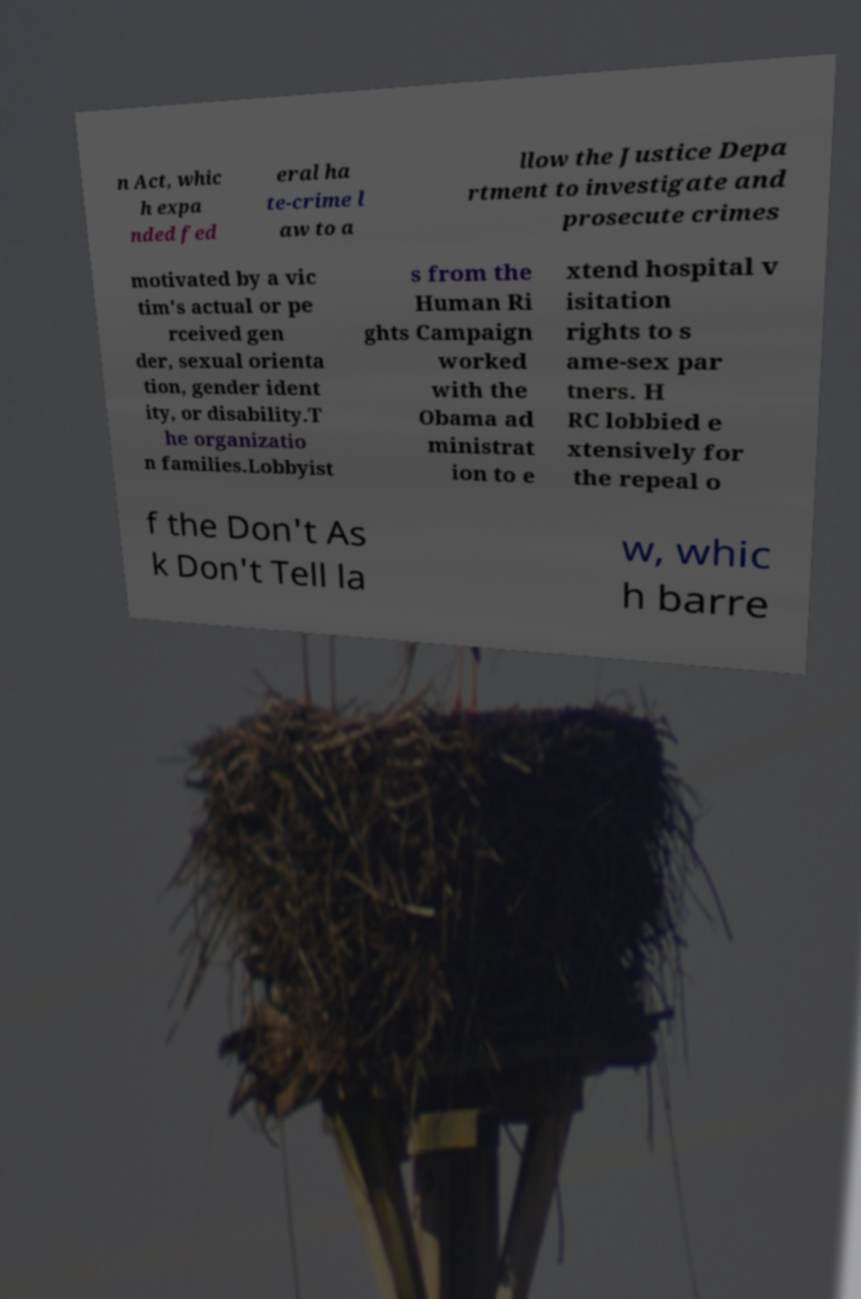Please read and relay the text visible in this image. What does it say? n Act, whic h expa nded fed eral ha te-crime l aw to a llow the Justice Depa rtment to investigate and prosecute crimes motivated by a vic tim's actual or pe rceived gen der, sexual orienta tion, gender ident ity, or disability.T he organizatio n families.Lobbyist s from the Human Ri ghts Campaign worked with the Obama ad ministrat ion to e xtend hospital v isitation rights to s ame-sex par tners. H RC lobbied e xtensively for the repeal o f the Don't As k Don't Tell la w, whic h barre 